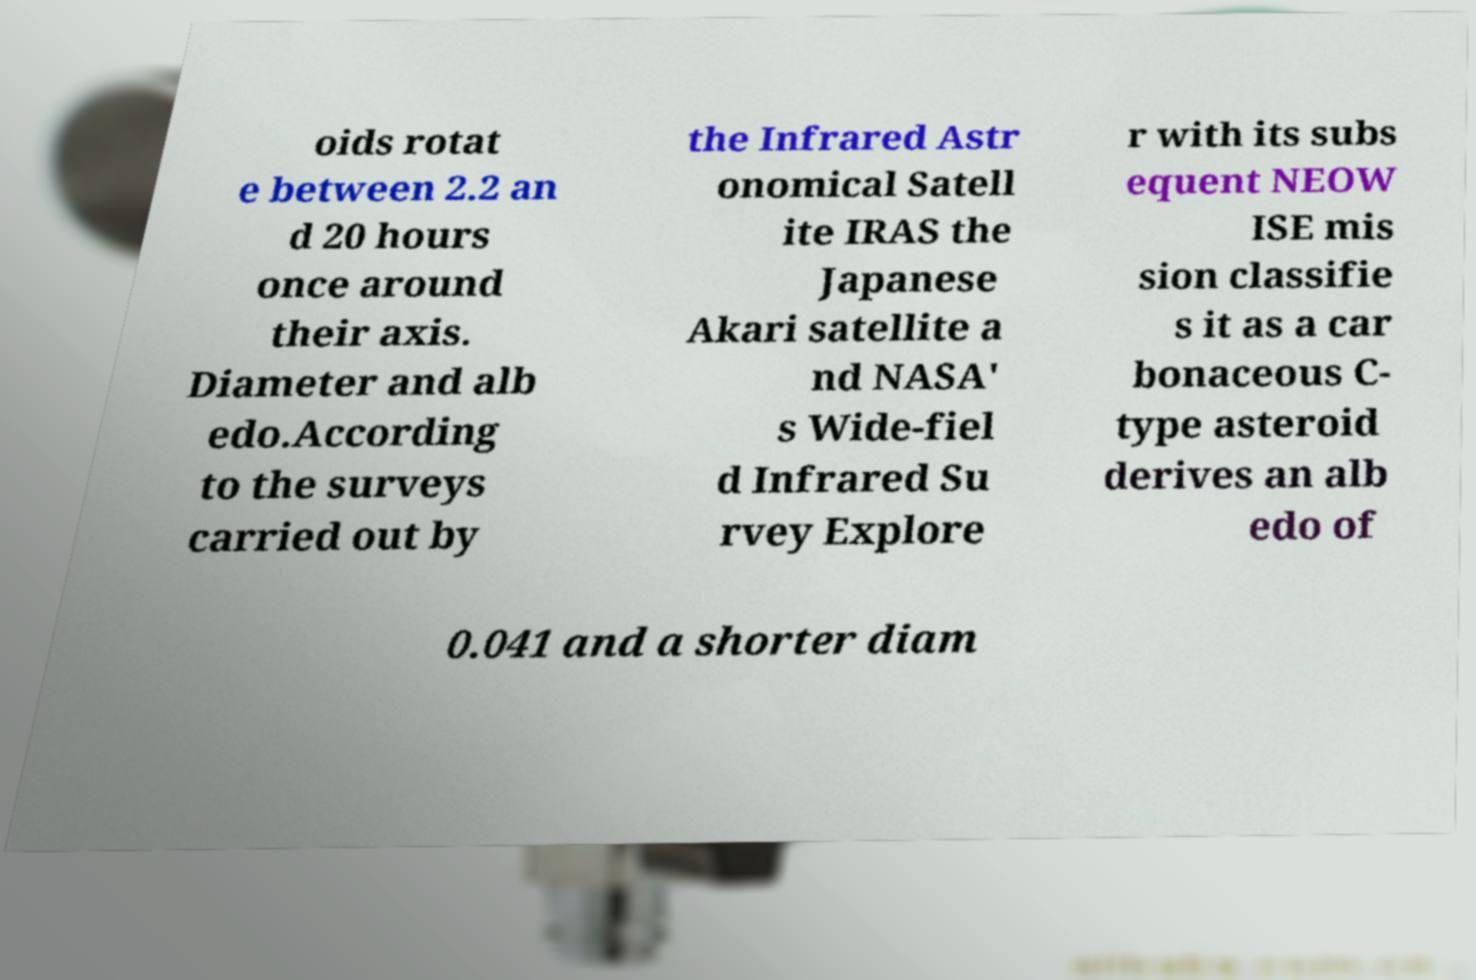Could you extract and type out the text from this image? oids rotat e between 2.2 an d 20 hours once around their axis. Diameter and alb edo.According to the surveys carried out by the Infrared Astr onomical Satell ite IRAS the Japanese Akari satellite a nd NASA' s Wide-fiel d Infrared Su rvey Explore r with its subs equent NEOW ISE mis sion classifie s it as a car bonaceous C- type asteroid derives an alb edo of 0.041 and a shorter diam 